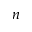Convert formula to latex. <formula><loc_0><loc_0><loc_500><loc_500>n</formula> 